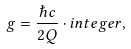Convert formula to latex. <formula><loc_0><loc_0><loc_500><loc_500>g = \frac { \hbar { c } } { 2 Q } \cdot i n t e g e r ,</formula> 